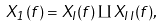<formula> <loc_0><loc_0><loc_500><loc_500>X _ { 1 } ( f ) = X _ { I } ( f ) \amalg X _ { I \, I } ( f ) ,</formula> 